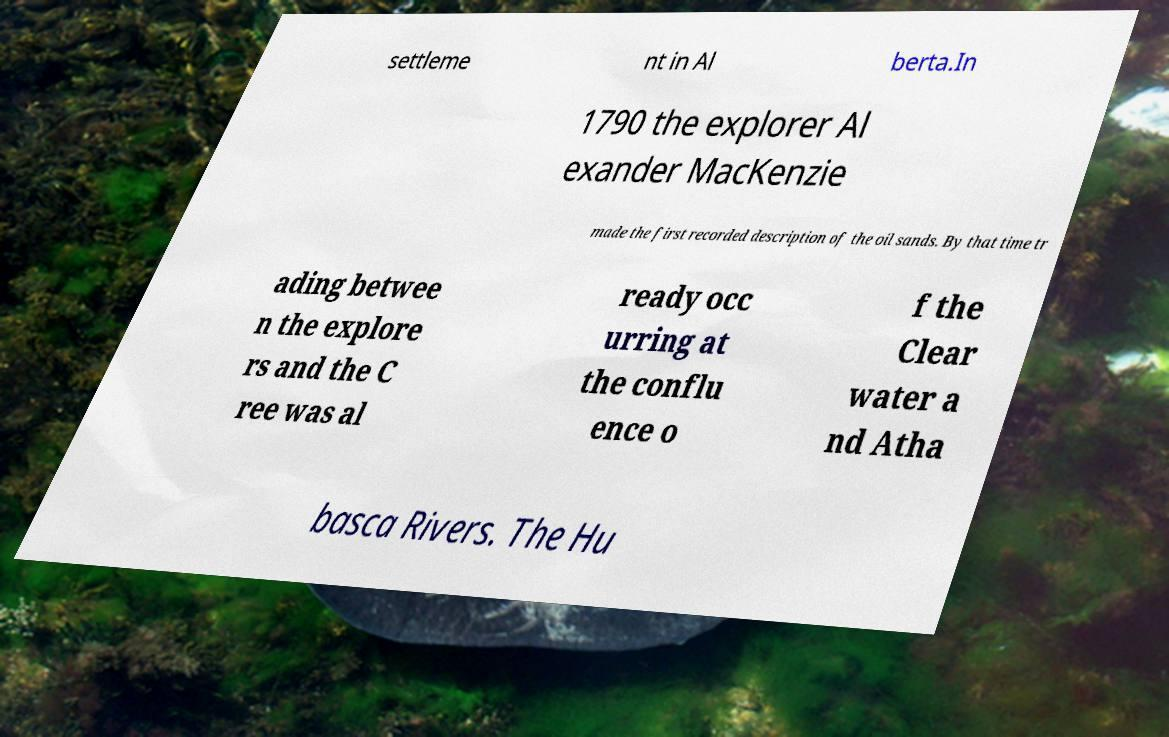There's text embedded in this image that I need extracted. Can you transcribe it verbatim? settleme nt in Al berta.In 1790 the explorer Al exander MacKenzie made the first recorded description of the oil sands. By that time tr ading betwee n the explore rs and the C ree was al ready occ urring at the conflu ence o f the Clear water a nd Atha basca Rivers. The Hu 